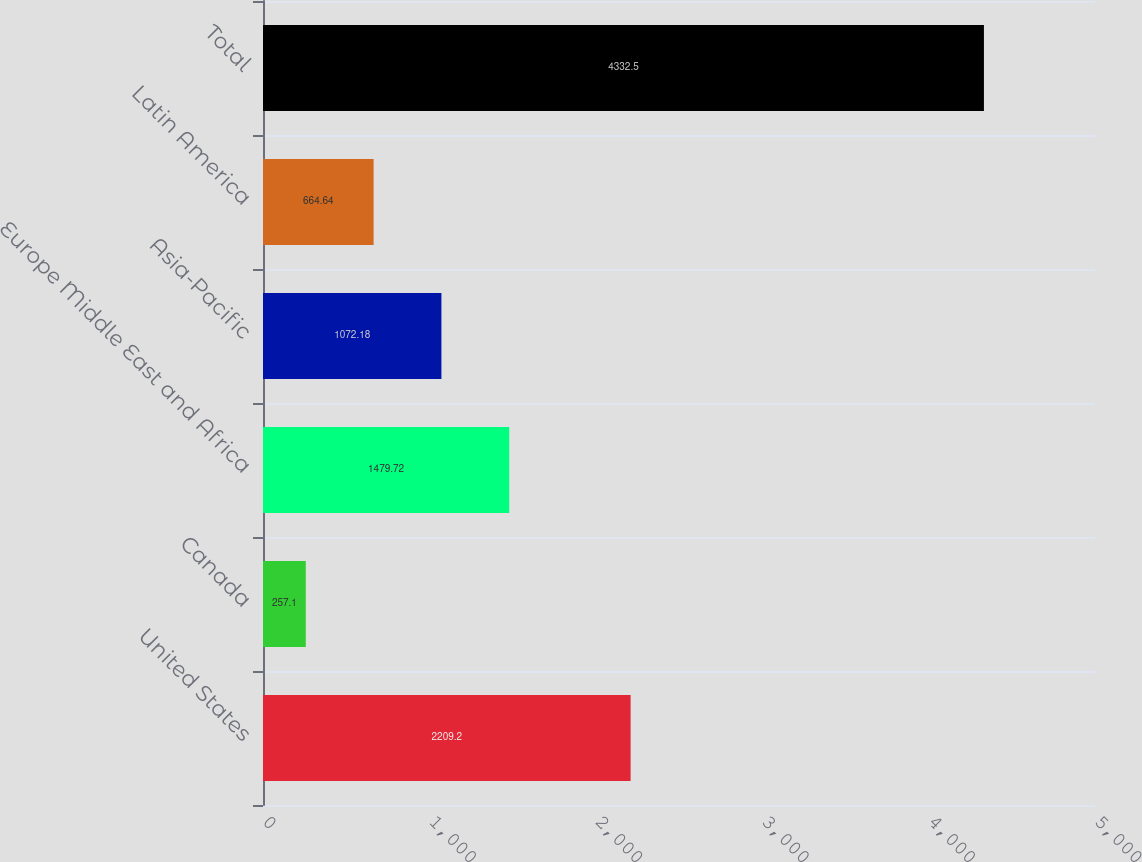Convert chart. <chart><loc_0><loc_0><loc_500><loc_500><bar_chart><fcel>United States<fcel>Canada<fcel>Europe Middle East and Africa<fcel>Asia-Pacific<fcel>Latin America<fcel>Total<nl><fcel>2209.2<fcel>257.1<fcel>1479.72<fcel>1072.18<fcel>664.64<fcel>4332.5<nl></chart> 